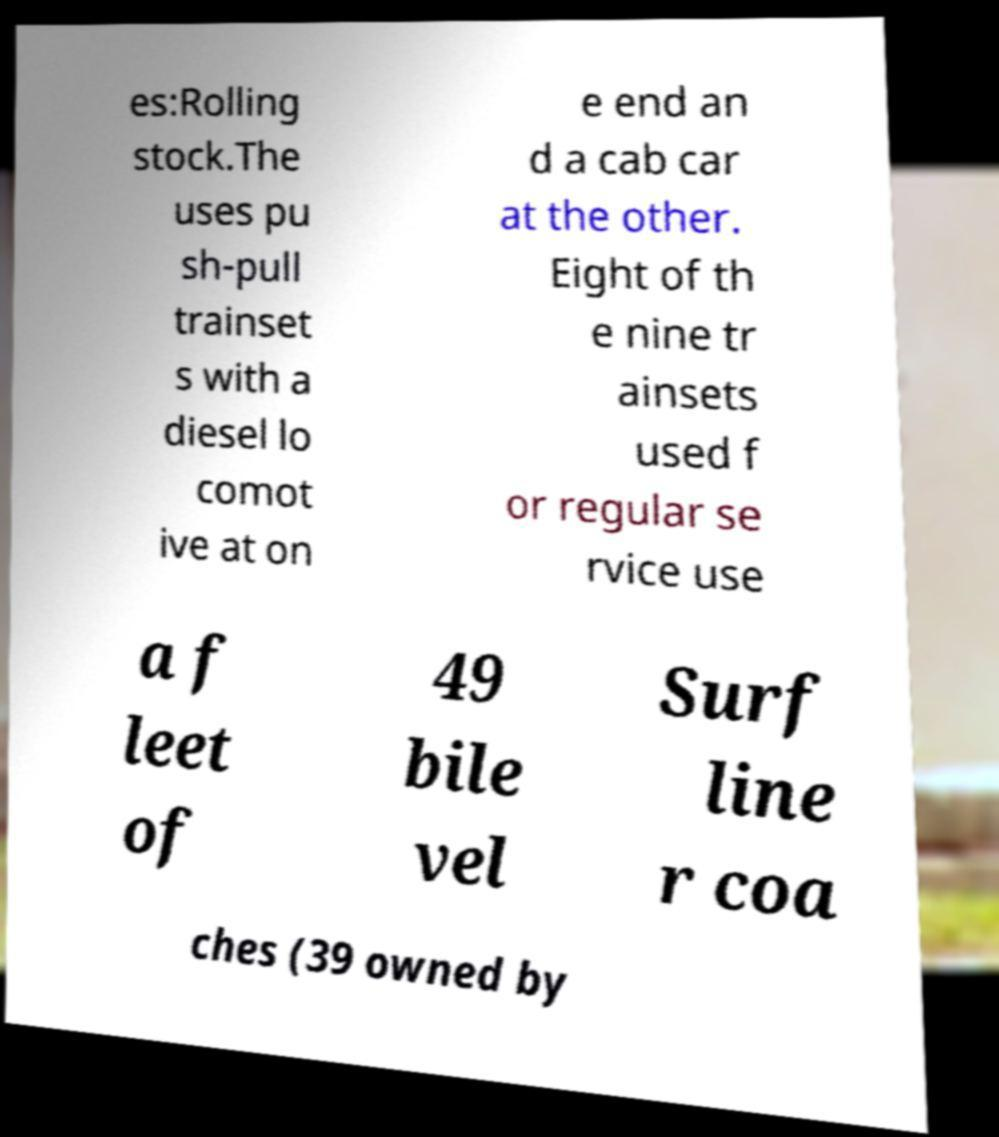There's text embedded in this image that I need extracted. Can you transcribe it verbatim? es:Rolling stock.The uses pu sh-pull trainset s with a diesel lo comot ive at on e end an d a cab car at the other. Eight of th e nine tr ainsets used f or regular se rvice use a f leet of 49 bile vel Surf line r coa ches (39 owned by 